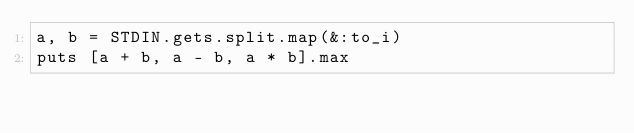<code> <loc_0><loc_0><loc_500><loc_500><_Ruby_>a, b = STDIN.gets.split.map(&:to_i)
puts [a + b, a - b, a * b].max
</code> 